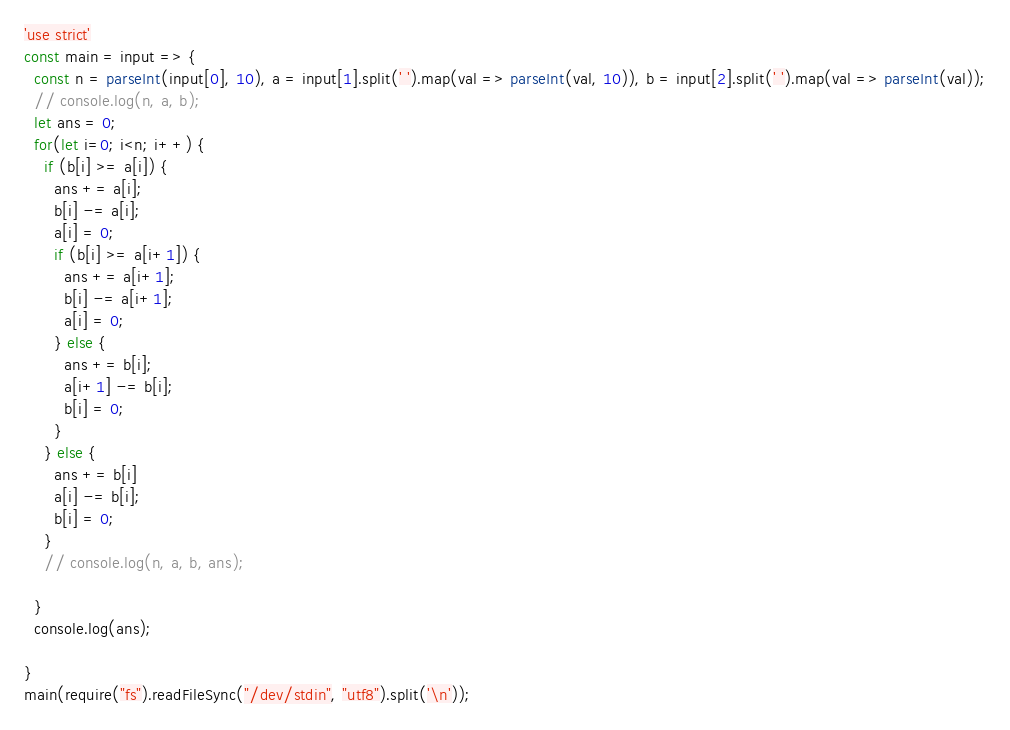Convert code to text. <code><loc_0><loc_0><loc_500><loc_500><_JavaScript_>'use strict'
const main = input => {
  const n = parseInt(input[0], 10), a = input[1].split(' ').map(val => parseInt(val, 10)), b = input[2].split(' ').map(val => parseInt(val));
  // console.log(n, a, b);
  let ans = 0;
  for(let i=0; i<n; i++) {
    if (b[i] >= a[i]) {
      ans += a[i];
      b[i] -= a[i];
      a[i] = 0;
      if (b[i] >= a[i+1]) {
        ans += a[i+1];
        b[i] -= a[i+1];
        a[i] = 0;
      } else {
        ans += b[i];
        a[i+1] -= b[i];
        b[i] = 0;
      }
    } else {
      ans += b[i]
      a[i] -= b[i];
      b[i] = 0;
    }
    // console.log(n, a, b, ans);
    
  }
  console.log(ans);
  
}
main(require("fs").readFileSync("/dev/stdin", "utf8").split('\n'));</code> 